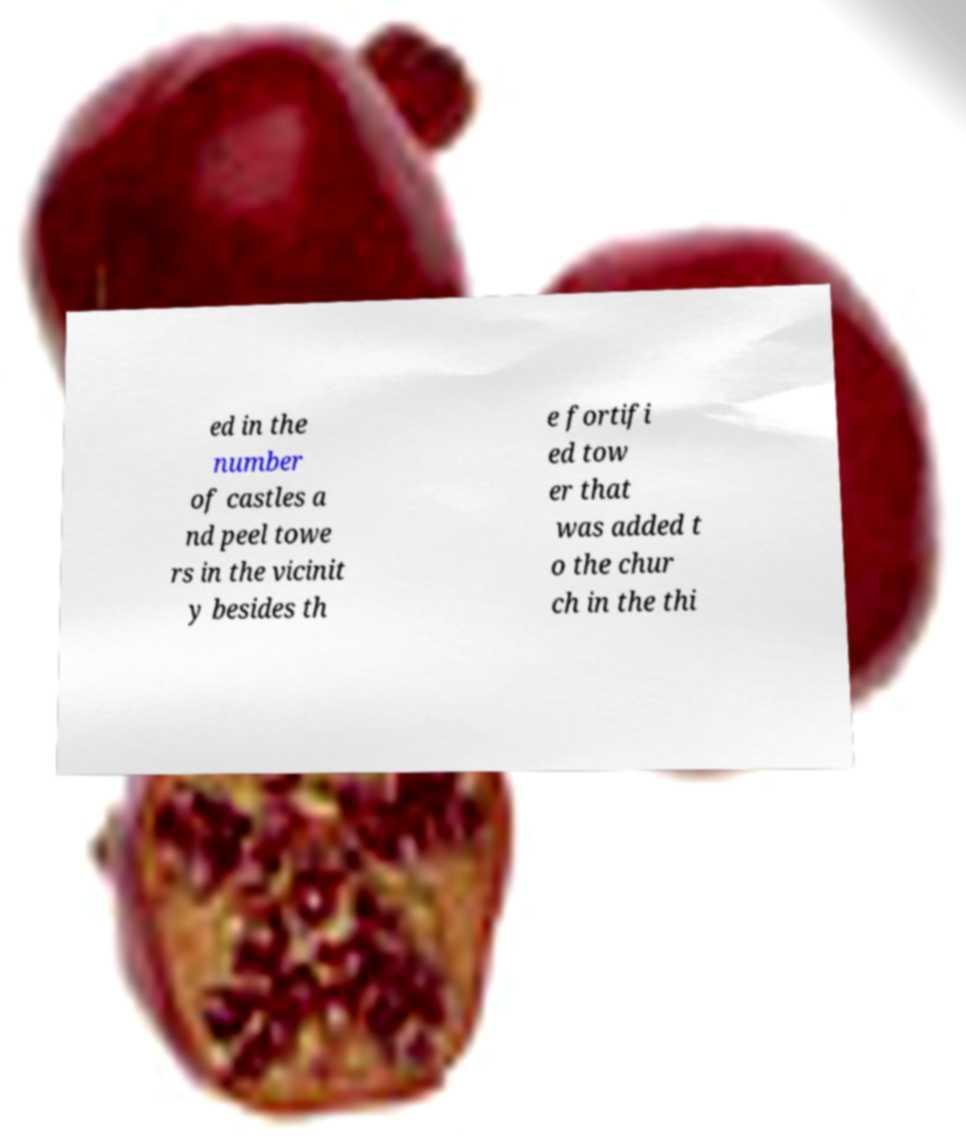For documentation purposes, I need the text within this image transcribed. Could you provide that? ed in the number of castles a nd peel towe rs in the vicinit y besides th e fortifi ed tow er that was added t o the chur ch in the thi 